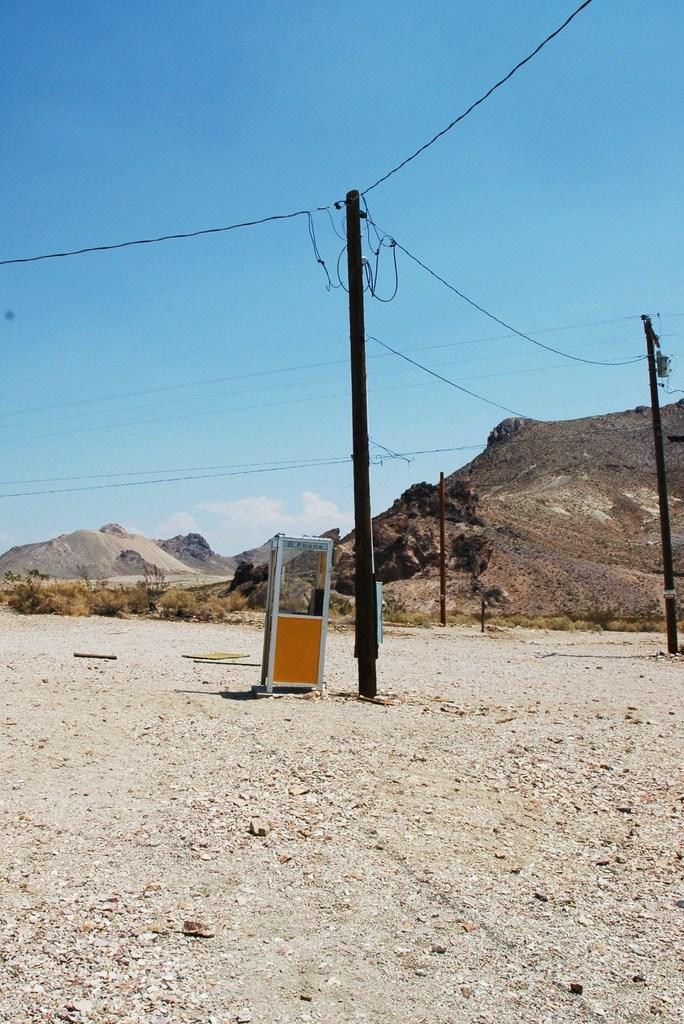Describe this image in one or two sentences. In this image I can see few electric poles. In front I can see the booth, background I can see the rock and the sky is in blue and white color. 